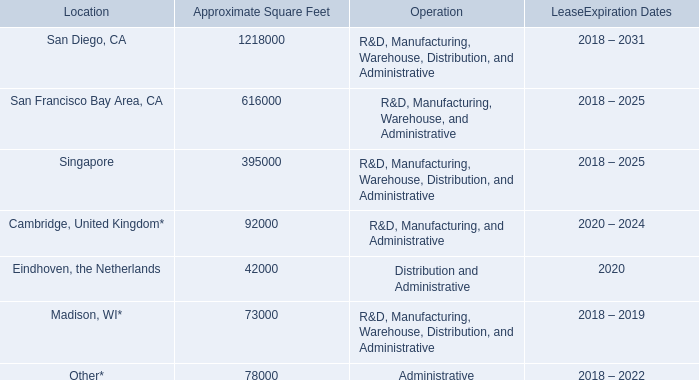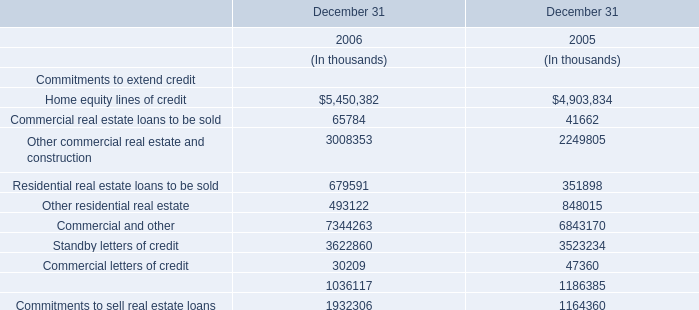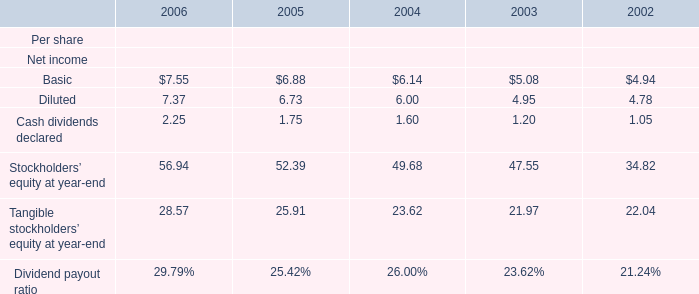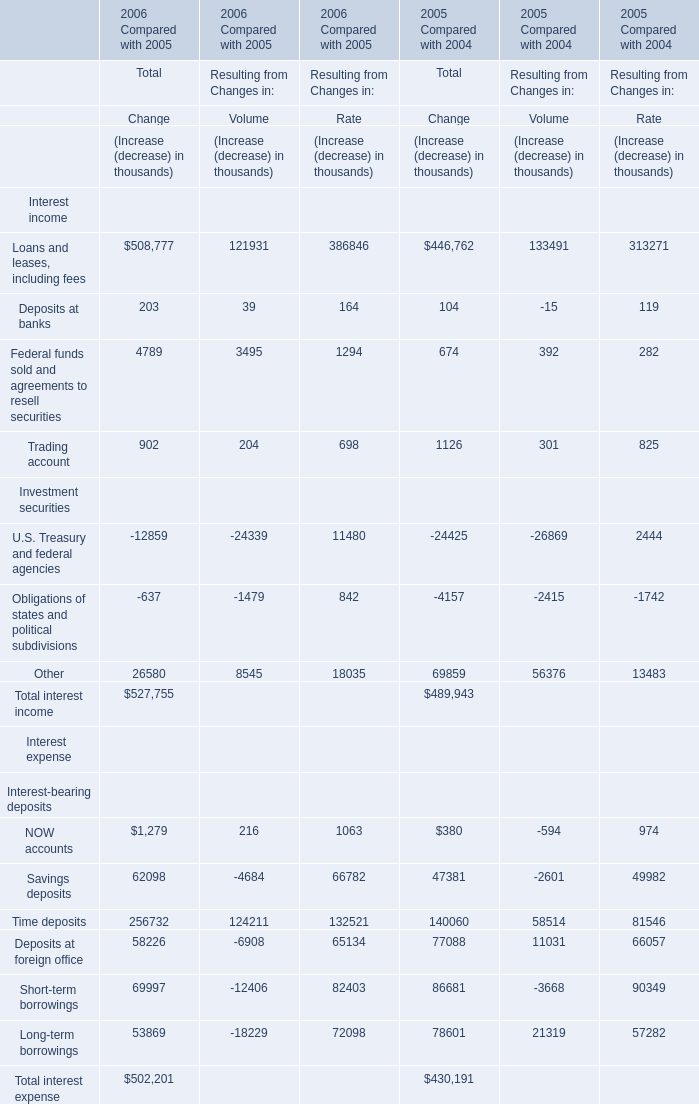What was the total amount of Total Change of Total interest income for 2006 Compared with 2005? (in thousand) 
Answer: 527755. 